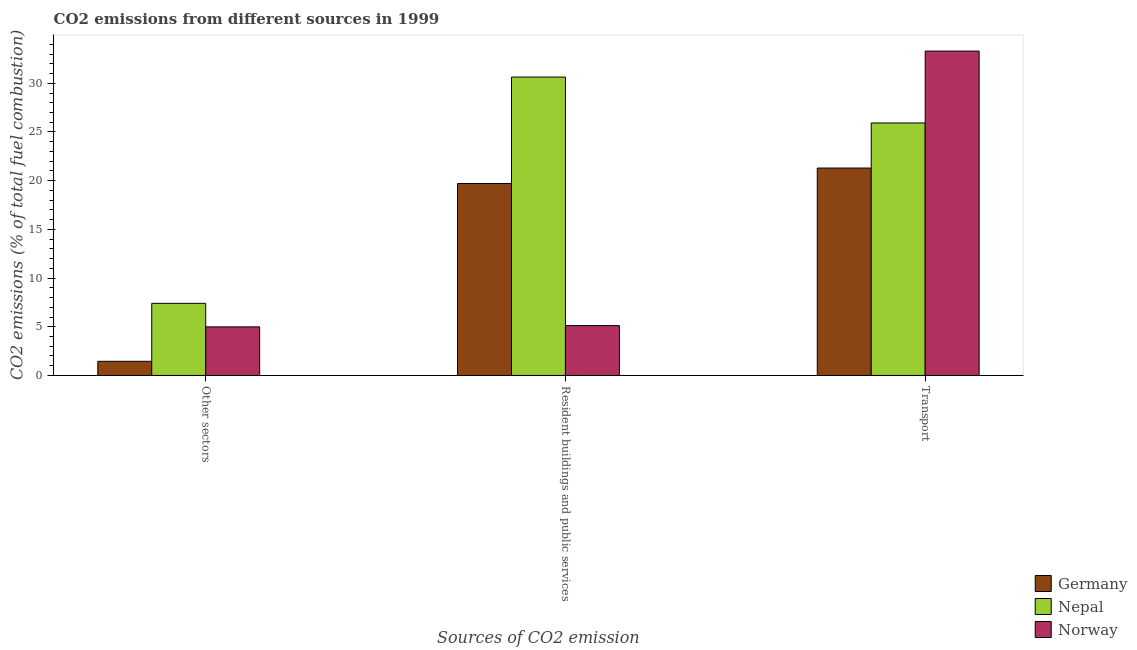What is the label of the 3rd group of bars from the left?
Your answer should be compact. Transport. What is the percentage of co2 emissions from transport in Nepal?
Make the answer very short. 25.93. Across all countries, what is the maximum percentage of co2 emissions from resident buildings and public services?
Offer a terse response. 30.64. Across all countries, what is the minimum percentage of co2 emissions from other sectors?
Provide a short and direct response. 1.45. In which country was the percentage of co2 emissions from other sectors maximum?
Provide a short and direct response. Nepal. What is the total percentage of co2 emissions from transport in the graph?
Your answer should be very brief. 80.53. What is the difference between the percentage of co2 emissions from transport in Norway and that in Nepal?
Provide a short and direct response. 7.38. What is the difference between the percentage of co2 emissions from resident buildings and public services in Germany and the percentage of co2 emissions from other sectors in Nepal?
Your answer should be very brief. 12.3. What is the average percentage of co2 emissions from transport per country?
Your response must be concise. 26.84. What is the difference between the percentage of co2 emissions from other sectors and percentage of co2 emissions from resident buildings and public services in Norway?
Offer a terse response. -0.13. What is the ratio of the percentage of co2 emissions from resident buildings and public services in Nepal to that in Norway?
Make the answer very short. 5.98. Is the percentage of co2 emissions from other sectors in Norway less than that in Nepal?
Give a very brief answer. Yes. Is the difference between the percentage of co2 emissions from resident buildings and public services in Germany and Nepal greater than the difference between the percentage of co2 emissions from transport in Germany and Nepal?
Keep it short and to the point. No. What is the difference between the highest and the second highest percentage of co2 emissions from other sectors?
Give a very brief answer. 2.42. What is the difference between the highest and the lowest percentage of co2 emissions from other sectors?
Provide a succinct answer. 5.95. Is the sum of the percentage of co2 emissions from transport in Norway and Nepal greater than the maximum percentage of co2 emissions from resident buildings and public services across all countries?
Give a very brief answer. Yes. What does the 1st bar from the left in Other sectors represents?
Offer a very short reply. Germany. Are all the bars in the graph horizontal?
Give a very brief answer. No. How many countries are there in the graph?
Provide a succinct answer. 3. What is the difference between two consecutive major ticks on the Y-axis?
Your answer should be compact. 5. Are the values on the major ticks of Y-axis written in scientific E-notation?
Offer a terse response. No. Where does the legend appear in the graph?
Your response must be concise. Bottom right. How many legend labels are there?
Make the answer very short. 3. How are the legend labels stacked?
Offer a very short reply. Vertical. What is the title of the graph?
Keep it short and to the point. CO2 emissions from different sources in 1999. Does "Timor-Leste" appear as one of the legend labels in the graph?
Provide a succinct answer. No. What is the label or title of the X-axis?
Give a very brief answer. Sources of CO2 emission. What is the label or title of the Y-axis?
Offer a very short reply. CO2 emissions (% of total fuel combustion). What is the CO2 emissions (% of total fuel combustion) of Germany in Other sectors?
Your response must be concise. 1.45. What is the CO2 emissions (% of total fuel combustion) of Nepal in Other sectors?
Provide a short and direct response. 7.41. What is the CO2 emissions (% of total fuel combustion) of Norway in Other sectors?
Keep it short and to the point. 4.99. What is the CO2 emissions (% of total fuel combustion) in Germany in Resident buildings and public services?
Offer a terse response. 19.71. What is the CO2 emissions (% of total fuel combustion) in Nepal in Resident buildings and public services?
Your answer should be very brief. 30.64. What is the CO2 emissions (% of total fuel combustion) in Norway in Resident buildings and public services?
Provide a short and direct response. 5.12. What is the CO2 emissions (% of total fuel combustion) of Germany in Transport?
Keep it short and to the point. 21.3. What is the CO2 emissions (% of total fuel combustion) in Nepal in Transport?
Provide a succinct answer. 25.93. What is the CO2 emissions (% of total fuel combustion) of Norway in Transport?
Your answer should be compact. 33.31. Across all Sources of CO2 emission, what is the maximum CO2 emissions (% of total fuel combustion) in Germany?
Offer a terse response. 21.3. Across all Sources of CO2 emission, what is the maximum CO2 emissions (% of total fuel combustion) of Nepal?
Offer a very short reply. 30.64. Across all Sources of CO2 emission, what is the maximum CO2 emissions (% of total fuel combustion) in Norway?
Offer a very short reply. 33.31. Across all Sources of CO2 emission, what is the minimum CO2 emissions (% of total fuel combustion) in Germany?
Your answer should be compact. 1.45. Across all Sources of CO2 emission, what is the minimum CO2 emissions (% of total fuel combustion) in Nepal?
Ensure brevity in your answer.  7.41. Across all Sources of CO2 emission, what is the minimum CO2 emissions (% of total fuel combustion) in Norway?
Provide a short and direct response. 4.99. What is the total CO2 emissions (% of total fuel combustion) of Germany in the graph?
Make the answer very short. 42.46. What is the total CO2 emissions (% of total fuel combustion) in Nepal in the graph?
Provide a succinct answer. 63.97. What is the total CO2 emissions (% of total fuel combustion) in Norway in the graph?
Keep it short and to the point. 43.42. What is the difference between the CO2 emissions (% of total fuel combustion) in Germany in Other sectors and that in Resident buildings and public services?
Ensure brevity in your answer.  -18.26. What is the difference between the CO2 emissions (% of total fuel combustion) of Nepal in Other sectors and that in Resident buildings and public services?
Make the answer very short. -23.23. What is the difference between the CO2 emissions (% of total fuel combustion) in Norway in Other sectors and that in Resident buildings and public services?
Ensure brevity in your answer.  -0.13. What is the difference between the CO2 emissions (% of total fuel combustion) of Germany in Other sectors and that in Transport?
Ensure brevity in your answer.  -19.85. What is the difference between the CO2 emissions (% of total fuel combustion) of Nepal in Other sectors and that in Transport?
Provide a short and direct response. -18.52. What is the difference between the CO2 emissions (% of total fuel combustion) in Norway in Other sectors and that in Transport?
Keep it short and to the point. -28.32. What is the difference between the CO2 emissions (% of total fuel combustion) of Germany in Resident buildings and public services and that in Transport?
Keep it short and to the point. -1.59. What is the difference between the CO2 emissions (% of total fuel combustion) in Nepal in Resident buildings and public services and that in Transport?
Offer a terse response. 4.71. What is the difference between the CO2 emissions (% of total fuel combustion) of Norway in Resident buildings and public services and that in Transport?
Make the answer very short. -28.19. What is the difference between the CO2 emissions (% of total fuel combustion) in Germany in Other sectors and the CO2 emissions (% of total fuel combustion) in Nepal in Resident buildings and public services?
Ensure brevity in your answer.  -29.19. What is the difference between the CO2 emissions (% of total fuel combustion) of Germany in Other sectors and the CO2 emissions (% of total fuel combustion) of Norway in Resident buildings and public services?
Your answer should be compact. -3.67. What is the difference between the CO2 emissions (% of total fuel combustion) of Nepal in Other sectors and the CO2 emissions (% of total fuel combustion) of Norway in Resident buildings and public services?
Your response must be concise. 2.29. What is the difference between the CO2 emissions (% of total fuel combustion) in Germany in Other sectors and the CO2 emissions (% of total fuel combustion) in Nepal in Transport?
Keep it short and to the point. -24.47. What is the difference between the CO2 emissions (% of total fuel combustion) in Germany in Other sectors and the CO2 emissions (% of total fuel combustion) in Norway in Transport?
Keep it short and to the point. -31.85. What is the difference between the CO2 emissions (% of total fuel combustion) in Nepal in Other sectors and the CO2 emissions (% of total fuel combustion) in Norway in Transport?
Ensure brevity in your answer.  -25.9. What is the difference between the CO2 emissions (% of total fuel combustion) of Germany in Resident buildings and public services and the CO2 emissions (% of total fuel combustion) of Nepal in Transport?
Offer a very short reply. -6.21. What is the difference between the CO2 emissions (% of total fuel combustion) in Germany in Resident buildings and public services and the CO2 emissions (% of total fuel combustion) in Norway in Transport?
Provide a succinct answer. -13.6. What is the difference between the CO2 emissions (% of total fuel combustion) in Nepal in Resident buildings and public services and the CO2 emissions (% of total fuel combustion) in Norway in Transport?
Offer a very short reply. -2.67. What is the average CO2 emissions (% of total fuel combustion) in Germany per Sources of CO2 emission?
Your response must be concise. 14.15. What is the average CO2 emissions (% of total fuel combustion) of Nepal per Sources of CO2 emission?
Ensure brevity in your answer.  21.32. What is the average CO2 emissions (% of total fuel combustion) in Norway per Sources of CO2 emission?
Ensure brevity in your answer.  14.47. What is the difference between the CO2 emissions (% of total fuel combustion) in Germany and CO2 emissions (% of total fuel combustion) in Nepal in Other sectors?
Make the answer very short. -5.95. What is the difference between the CO2 emissions (% of total fuel combustion) in Germany and CO2 emissions (% of total fuel combustion) in Norway in Other sectors?
Give a very brief answer. -3.54. What is the difference between the CO2 emissions (% of total fuel combustion) of Nepal and CO2 emissions (% of total fuel combustion) of Norway in Other sectors?
Your answer should be very brief. 2.42. What is the difference between the CO2 emissions (% of total fuel combustion) of Germany and CO2 emissions (% of total fuel combustion) of Nepal in Resident buildings and public services?
Make the answer very short. -10.93. What is the difference between the CO2 emissions (% of total fuel combustion) of Germany and CO2 emissions (% of total fuel combustion) of Norway in Resident buildings and public services?
Your response must be concise. 14.59. What is the difference between the CO2 emissions (% of total fuel combustion) in Nepal and CO2 emissions (% of total fuel combustion) in Norway in Resident buildings and public services?
Provide a succinct answer. 25.52. What is the difference between the CO2 emissions (% of total fuel combustion) of Germany and CO2 emissions (% of total fuel combustion) of Nepal in Transport?
Ensure brevity in your answer.  -4.63. What is the difference between the CO2 emissions (% of total fuel combustion) of Germany and CO2 emissions (% of total fuel combustion) of Norway in Transport?
Give a very brief answer. -12.01. What is the difference between the CO2 emissions (% of total fuel combustion) of Nepal and CO2 emissions (% of total fuel combustion) of Norway in Transport?
Ensure brevity in your answer.  -7.38. What is the ratio of the CO2 emissions (% of total fuel combustion) in Germany in Other sectors to that in Resident buildings and public services?
Offer a very short reply. 0.07. What is the ratio of the CO2 emissions (% of total fuel combustion) of Nepal in Other sectors to that in Resident buildings and public services?
Ensure brevity in your answer.  0.24. What is the ratio of the CO2 emissions (% of total fuel combustion) of Norway in Other sectors to that in Resident buildings and public services?
Your answer should be compact. 0.97. What is the ratio of the CO2 emissions (% of total fuel combustion) of Germany in Other sectors to that in Transport?
Ensure brevity in your answer.  0.07. What is the ratio of the CO2 emissions (% of total fuel combustion) of Nepal in Other sectors to that in Transport?
Give a very brief answer. 0.29. What is the ratio of the CO2 emissions (% of total fuel combustion) in Norway in Other sectors to that in Transport?
Offer a terse response. 0.15. What is the ratio of the CO2 emissions (% of total fuel combustion) of Germany in Resident buildings and public services to that in Transport?
Your response must be concise. 0.93. What is the ratio of the CO2 emissions (% of total fuel combustion) in Nepal in Resident buildings and public services to that in Transport?
Your answer should be compact. 1.18. What is the ratio of the CO2 emissions (% of total fuel combustion) of Norway in Resident buildings and public services to that in Transport?
Offer a very short reply. 0.15. What is the difference between the highest and the second highest CO2 emissions (% of total fuel combustion) in Germany?
Give a very brief answer. 1.59. What is the difference between the highest and the second highest CO2 emissions (% of total fuel combustion) in Nepal?
Keep it short and to the point. 4.71. What is the difference between the highest and the second highest CO2 emissions (% of total fuel combustion) in Norway?
Your answer should be compact. 28.19. What is the difference between the highest and the lowest CO2 emissions (% of total fuel combustion) in Germany?
Your response must be concise. 19.85. What is the difference between the highest and the lowest CO2 emissions (% of total fuel combustion) in Nepal?
Offer a terse response. 23.23. What is the difference between the highest and the lowest CO2 emissions (% of total fuel combustion) in Norway?
Your answer should be compact. 28.32. 